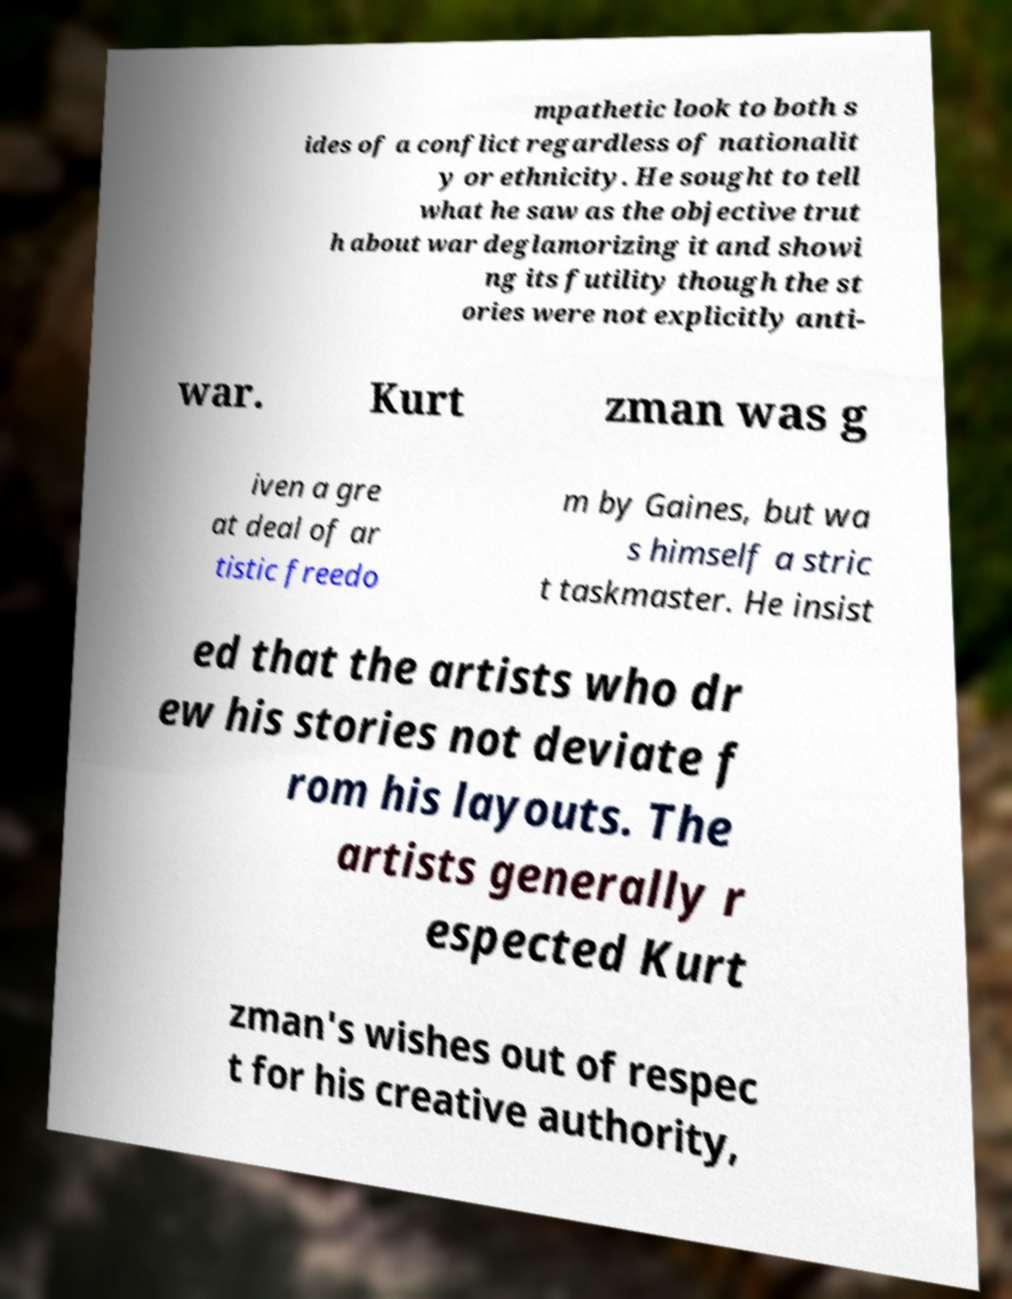Can you accurately transcribe the text from the provided image for me? mpathetic look to both s ides of a conflict regardless of nationalit y or ethnicity. He sought to tell what he saw as the objective trut h about war deglamorizing it and showi ng its futility though the st ories were not explicitly anti- war. Kurt zman was g iven a gre at deal of ar tistic freedo m by Gaines, but wa s himself a stric t taskmaster. He insist ed that the artists who dr ew his stories not deviate f rom his layouts. The artists generally r espected Kurt zman's wishes out of respec t for his creative authority, 